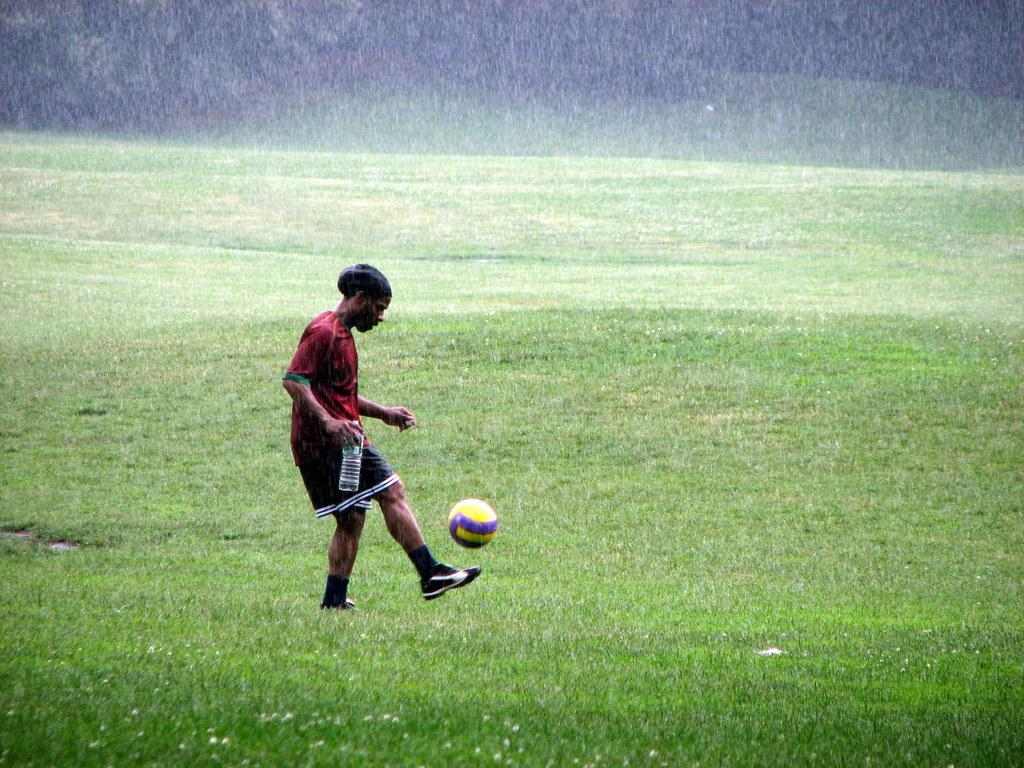What is the weather like in the image? It is raining in the image. What type of vegetation can be seen in the image? There are many trees in the image. What activity is the person engaged in? The person is playing with a ball. What type of terrain is visible in the image? There is a grassy land in the image. What type of stew is being served in the image? There is no stew present in the image; it features a person playing with a ball in a rainy environment with trees and grassy land. How many cakes are visible on the grassy land in the image? There are no cakes visible on the grassy land in the image. 